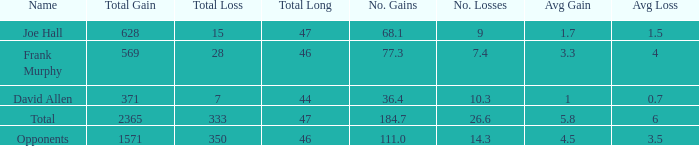How much Loss has a Gain smaller than 1571, and a Long smaller than 47, and an Avg/G of 36.4? 1.0. 